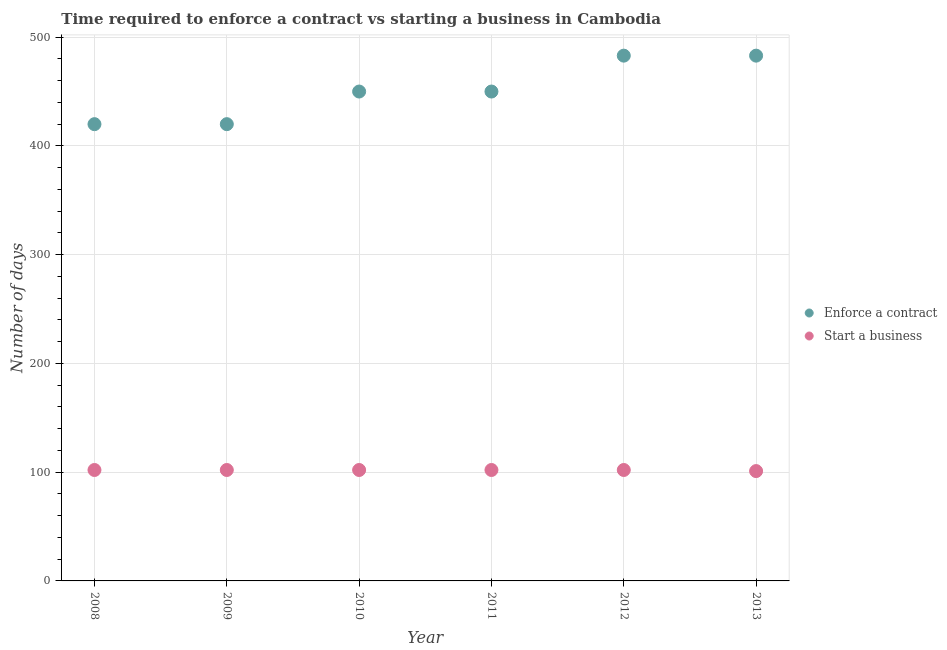How many different coloured dotlines are there?
Your response must be concise. 2. Is the number of dotlines equal to the number of legend labels?
Offer a very short reply. Yes. What is the number of days to enforece a contract in 2008?
Your answer should be very brief. 420. Across all years, what is the maximum number of days to start a business?
Provide a short and direct response. 102. Across all years, what is the minimum number of days to start a business?
Your answer should be very brief. 101. In which year was the number of days to start a business maximum?
Offer a terse response. 2008. In which year was the number of days to start a business minimum?
Make the answer very short. 2013. What is the total number of days to start a business in the graph?
Make the answer very short. 611. What is the difference between the number of days to enforece a contract in 2009 and that in 2012?
Provide a succinct answer. -63. What is the difference between the number of days to start a business in 2011 and the number of days to enforece a contract in 2012?
Your response must be concise. -381. What is the average number of days to enforece a contract per year?
Offer a terse response. 451. In the year 2010, what is the difference between the number of days to start a business and number of days to enforece a contract?
Keep it short and to the point. -348. What is the ratio of the number of days to enforece a contract in 2008 to that in 2013?
Provide a succinct answer. 0.87. What is the difference between the highest and the lowest number of days to enforece a contract?
Offer a very short reply. 63. In how many years, is the number of days to enforece a contract greater than the average number of days to enforece a contract taken over all years?
Your answer should be compact. 2. Is the sum of the number of days to start a business in 2010 and 2013 greater than the maximum number of days to enforece a contract across all years?
Your answer should be very brief. No. Does the number of days to enforece a contract monotonically increase over the years?
Provide a short and direct response. No. Is the number of days to start a business strictly greater than the number of days to enforece a contract over the years?
Offer a terse response. No. Is the number of days to enforece a contract strictly less than the number of days to start a business over the years?
Provide a succinct answer. No. How many years are there in the graph?
Your response must be concise. 6. Are the values on the major ticks of Y-axis written in scientific E-notation?
Provide a succinct answer. No. Does the graph contain any zero values?
Your answer should be very brief. No. How many legend labels are there?
Provide a succinct answer. 2. What is the title of the graph?
Offer a very short reply. Time required to enforce a contract vs starting a business in Cambodia. What is the label or title of the X-axis?
Your answer should be very brief. Year. What is the label or title of the Y-axis?
Provide a succinct answer. Number of days. What is the Number of days of Enforce a contract in 2008?
Offer a terse response. 420. What is the Number of days in Start a business in 2008?
Your response must be concise. 102. What is the Number of days of Enforce a contract in 2009?
Give a very brief answer. 420. What is the Number of days of Start a business in 2009?
Ensure brevity in your answer.  102. What is the Number of days of Enforce a contract in 2010?
Make the answer very short. 450. What is the Number of days of Start a business in 2010?
Give a very brief answer. 102. What is the Number of days in Enforce a contract in 2011?
Your answer should be very brief. 450. What is the Number of days in Start a business in 2011?
Keep it short and to the point. 102. What is the Number of days in Enforce a contract in 2012?
Provide a succinct answer. 483. What is the Number of days of Start a business in 2012?
Your response must be concise. 102. What is the Number of days of Enforce a contract in 2013?
Provide a short and direct response. 483. What is the Number of days of Start a business in 2013?
Make the answer very short. 101. Across all years, what is the maximum Number of days of Enforce a contract?
Keep it short and to the point. 483. Across all years, what is the maximum Number of days in Start a business?
Your answer should be very brief. 102. Across all years, what is the minimum Number of days of Enforce a contract?
Provide a succinct answer. 420. Across all years, what is the minimum Number of days in Start a business?
Provide a short and direct response. 101. What is the total Number of days of Enforce a contract in the graph?
Give a very brief answer. 2706. What is the total Number of days of Start a business in the graph?
Ensure brevity in your answer.  611. What is the difference between the Number of days in Enforce a contract in 2008 and that in 2010?
Keep it short and to the point. -30. What is the difference between the Number of days in Start a business in 2008 and that in 2010?
Make the answer very short. 0. What is the difference between the Number of days in Enforce a contract in 2008 and that in 2011?
Ensure brevity in your answer.  -30. What is the difference between the Number of days of Start a business in 2008 and that in 2011?
Ensure brevity in your answer.  0. What is the difference between the Number of days in Enforce a contract in 2008 and that in 2012?
Provide a short and direct response. -63. What is the difference between the Number of days of Start a business in 2008 and that in 2012?
Your answer should be compact. 0. What is the difference between the Number of days in Enforce a contract in 2008 and that in 2013?
Ensure brevity in your answer.  -63. What is the difference between the Number of days in Start a business in 2008 and that in 2013?
Offer a very short reply. 1. What is the difference between the Number of days in Start a business in 2009 and that in 2010?
Your answer should be compact. 0. What is the difference between the Number of days of Enforce a contract in 2009 and that in 2011?
Give a very brief answer. -30. What is the difference between the Number of days of Start a business in 2009 and that in 2011?
Offer a terse response. 0. What is the difference between the Number of days in Enforce a contract in 2009 and that in 2012?
Keep it short and to the point. -63. What is the difference between the Number of days of Start a business in 2009 and that in 2012?
Keep it short and to the point. 0. What is the difference between the Number of days in Enforce a contract in 2009 and that in 2013?
Your response must be concise. -63. What is the difference between the Number of days in Enforce a contract in 2010 and that in 2011?
Provide a succinct answer. 0. What is the difference between the Number of days in Start a business in 2010 and that in 2011?
Your response must be concise. 0. What is the difference between the Number of days of Enforce a contract in 2010 and that in 2012?
Make the answer very short. -33. What is the difference between the Number of days of Start a business in 2010 and that in 2012?
Provide a short and direct response. 0. What is the difference between the Number of days of Enforce a contract in 2010 and that in 2013?
Provide a short and direct response. -33. What is the difference between the Number of days of Start a business in 2010 and that in 2013?
Your answer should be very brief. 1. What is the difference between the Number of days of Enforce a contract in 2011 and that in 2012?
Make the answer very short. -33. What is the difference between the Number of days of Enforce a contract in 2011 and that in 2013?
Provide a succinct answer. -33. What is the difference between the Number of days of Enforce a contract in 2012 and that in 2013?
Offer a very short reply. 0. What is the difference between the Number of days of Start a business in 2012 and that in 2013?
Keep it short and to the point. 1. What is the difference between the Number of days of Enforce a contract in 2008 and the Number of days of Start a business in 2009?
Your response must be concise. 318. What is the difference between the Number of days of Enforce a contract in 2008 and the Number of days of Start a business in 2010?
Provide a succinct answer. 318. What is the difference between the Number of days of Enforce a contract in 2008 and the Number of days of Start a business in 2011?
Provide a short and direct response. 318. What is the difference between the Number of days of Enforce a contract in 2008 and the Number of days of Start a business in 2012?
Offer a very short reply. 318. What is the difference between the Number of days in Enforce a contract in 2008 and the Number of days in Start a business in 2013?
Your answer should be very brief. 319. What is the difference between the Number of days in Enforce a contract in 2009 and the Number of days in Start a business in 2010?
Offer a terse response. 318. What is the difference between the Number of days of Enforce a contract in 2009 and the Number of days of Start a business in 2011?
Provide a succinct answer. 318. What is the difference between the Number of days in Enforce a contract in 2009 and the Number of days in Start a business in 2012?
Ensure brevity in your answer.  318. What is the difference between the Number of days in Enforce a contract in 2009 and the Number of days in Start a business in 2013?
Provide a succinct answer. 319. What is the difference between the Number of days in Enforce a contract in 2010 and the Number of days in Start a business in 2011?
Give a very brief answer. 348. What is the difference between the Number of days in Enforce a contract in 2010 and the Number of days in Start a business in 2012?
Your response must be concise. 348. What is the difference between the Number of days in Enforce a contract in 2010 and the Number of days in Start a business in 2013?
Provide a succinct answer. 349. What is the difference between the Number of days of Enforce a contract in 2011 and the Number of days of Start a business in 2012?
Offer a very short reply. 348. What is the difference between the Number of days of Enforce a contract in 2011 and the Number of days of Start a business in 2013?
Offer a terse response. 349. What is the difference between the Number of days in Enforce a contract in 2012 and the Number of days in Start a business in 2013?
Make the answer very short. 382. What is the average Number of days in Enforce a contract per year?
Your response must be concise. 451. What is the average Number of days of Start a business per year?
Provide a succinct answer. 101.83. In the year 2008, what is the difference between the Number of days in Enforce a contract and Number of days in Start a business?
Your response must be concise. 318. In the year 2009, what is the difference between the Number of days in Enforce a contract and Number of days in Start a business?
Your answer should be compact. 318. In the year 2010, what is the difference between the Number of days of Enforce a contract and Number of days of Start a business?
Give a very brief answer. 348. In the year 2011, what is the difference between the Number of days of Enforce a contract and Number of days of Start a business?
Provide a short and direct response. 348. In the year 2012, what is the difference between the Number of days of Enforce a contract and Number of days of Start a business?
Offer a terse response. 381. In the year 2013, what is the difference between the Number of days of Enforce a contract and Number of days of Start a business?
Offer a very short reply. 382. What is the ratio of the Number of days of Enforce a contract in 2008 to that in 2009?
Your answer should be compact. 1. What is the ratio of the Number of days of Enforce a contract in 2008 to that in 2010?
Your answer should be very brief. 0.93. What is the ratio of the Number of days in Enforce a contract in 2008 to that in 2011?
Provide a succinct answer. 0.93. What is the ratio of the Number of days in Enforce a contract in 2008 to that in 2012?
Your answer should be compact. 0.87. What is the ratio of the Number of days of Start a business in 2008 to that in 2012?
Your response must be concise. 1. What is the ratio of the Number of days in Enforce a contract in 2008 to that in 2013?
Ensure brevity in your answer.  0.87. What is the ratio of the Number of days of Start a business in 2008 to that in 2013?
Make the answer very short. 1.01. What is the ratio of the Number of days in Enforce a contract in 2009 to that in 2010?
Offer a terse response. 0.93. What is the ratio of the Number of days in Start a business in 2009 to that in 2010?
Provide a succinct answer. 1. What is the ratio of the Number of days of Start a business in 2009 to that in 2011?
Provide a succinct answer. 1. What is the ratio of the Number of days in Enforce a contract in 2009 to that in 2012?
Your answer should be very brief. 0.87. What is the ratio of the Number of days of Start a business in 2009 to that in 2012?
Your answer should be very brief. 1. What is the ratio of the Number of days of Enforce a contract in 2009 to that in 2013?
Provide a short and direct response. 0.87. What is the ratio of the Number of days in Start a business in 2009 to that in 2013?
Your answer should be very brief. 1.01. What is the ratio of the Number of days in Enforce a contract in 2010 to that in 2011?
Provide a short and direct response. 1. What is the ratio of the Number of days of Start a business in 2010 to that in 2011?
Offer a very short reply. 1. What is the ratio of the Number of days of Enforce a contract in 2010 to that in 2012?
Your response must be concise. 0.93. What is the ratio of the Number of days of Start a business in 2010 to that in 2012?
Your answer should be very brief. 1. What is the ratio of the Number of days in Enforce a contract in 2010 to that in 2013?
Keep it short and to the point. 0.93. What is the ratio of the Number of days in Start a business in 2010 to that in 2013?
Offer a very short reply. 1.01. What is the ratio of the Number of days of Enforce a contract in 2011 to that in 2012?
Provide a succinct answer. 0.93. What is the ratio of the Number of days in Start a business in 2011 to that in 2012?
Your answer should be very brief. 1. What is the ratio of the Number of days in Enforce a contract in 2011 to that in 2013?
Your answer should be compact. 0.93. What is the ratio of the Number of days of Start a business in 2011 to that in 2013?
Your response must be concise. 1.01. What is the ratio of the Number of days in Enforce a contract in 2012 to that in 2013?
Keep it short and to the point. 1. What is the ratio of the Number of days in Start a business in 2012 to that in 2013?
Your response must be concise. 1.01. What is the difference between the highest and the second highest Number of days in Enforce a contract?
Your answer should be very brief. 0. What is the difference between the highest and the lowest Number of days in Enforce a contract?
Give a very brief answer. 63. 